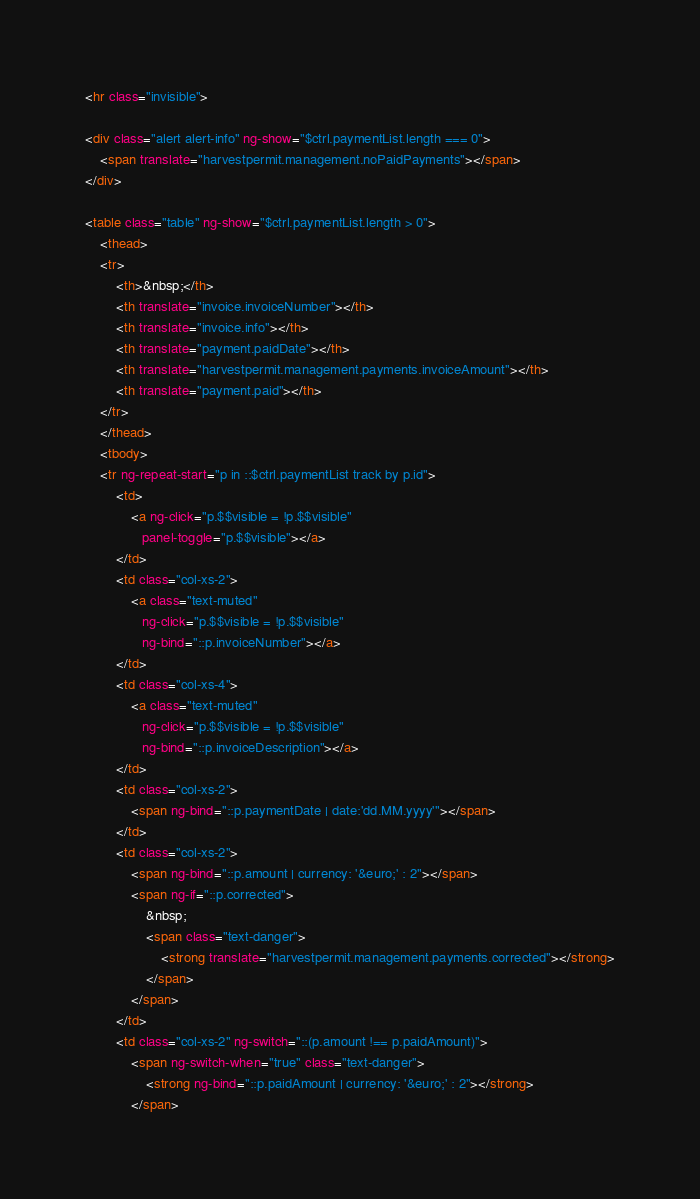Convert code to text. <code><loc_0><loc_0><loc_500><loc_500><_HTML_><hr class="invisible">

<div class="alert alert-info" ng-show="$ctrl.paymentList.length === 0">
    <span translate="harvestpermit.management.noPaidPayments"></span>
</div>

<table class="table" ng-show="$ctrl.paymentList.length > 0">
    <thead>
    <tr>
        <th>&nbsp;</th>
        <th translate="invoice.invoiceNumber"></th>
        <th translate="invoice.info"></th>
        <th translate="payment.paidDate"></th>
        <th translate="harvestpermit.management.payments.invoiceAmount"></th>
        <th translate="payment.paid"></th>
    </tr>
    </thead>
    <tbody>
    <tr ng-repeat-start="p in ::$ctrl.paymentList track by p.id">
        <td>
            <a ng-click="p.$$visible = !p.$$visible"
               panel-toggle="p.$$visible"></a>
        </td>
        <td class="col-xs-2">
            <a class="text-muted"
               ng-click="p.$$visible = !p.$$visible"
               ng-bind="::p.invoiceNumber"></a>
        </td>
        <td class="col-xs-4">
            <a class="text-muted"
               ng-click="p.$$visible = !p.$$visible"
               ng-bind="::p.invoiceDescription"></a>
        </td>
        <td class="col-xs-2">
            <span ng-bind="::p.paymentDate | date:'dd.MM.yyyy'"></span>
        </td>
        <td class="col-xs-2">
            <span ng-bind="::p.amount | currency: '&euro;' : 2"></span>
            <span ng-if="::p.corrected">
                &nbsp;
                <span class="text-danger">
                    <strong translate="harvestpermit.management.payments.corrected"></strong>
                </span>
            </span>
        </td>
        <td class="col-xs-2" ng-switch="::(p.amount !== p.paidAmount)">
            <span ng-switch-when="true" class="text-danger">
                <strong ng-bind="::p.paidAmount | currency: '&euro;' : 2"></strong>
            </span></code> 